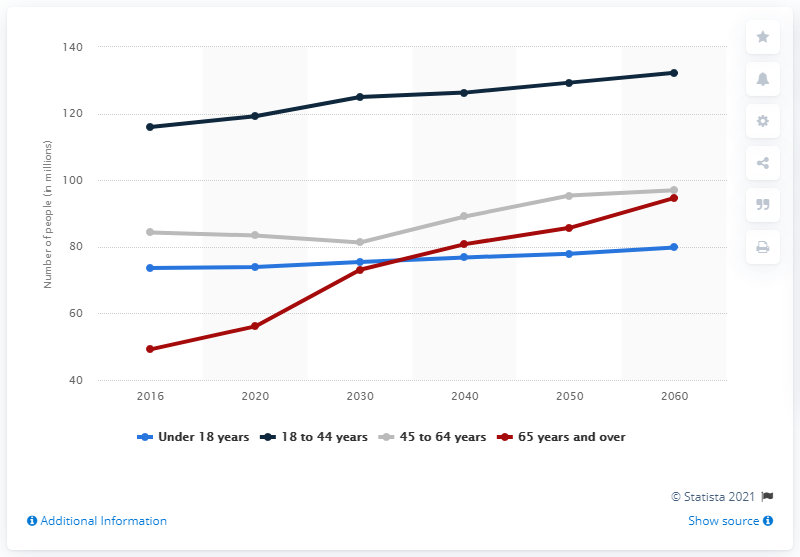Indicate a few pertinent items in this graphic. In 2020, it is projected that 73.9 Americans will reside within the United States. 